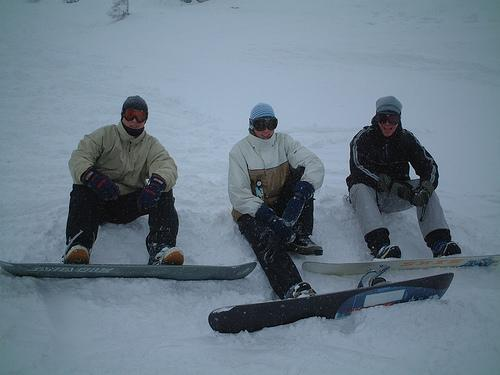Sitting like this allows the snowboarders to avoid doing what with their Snow boards? slide 